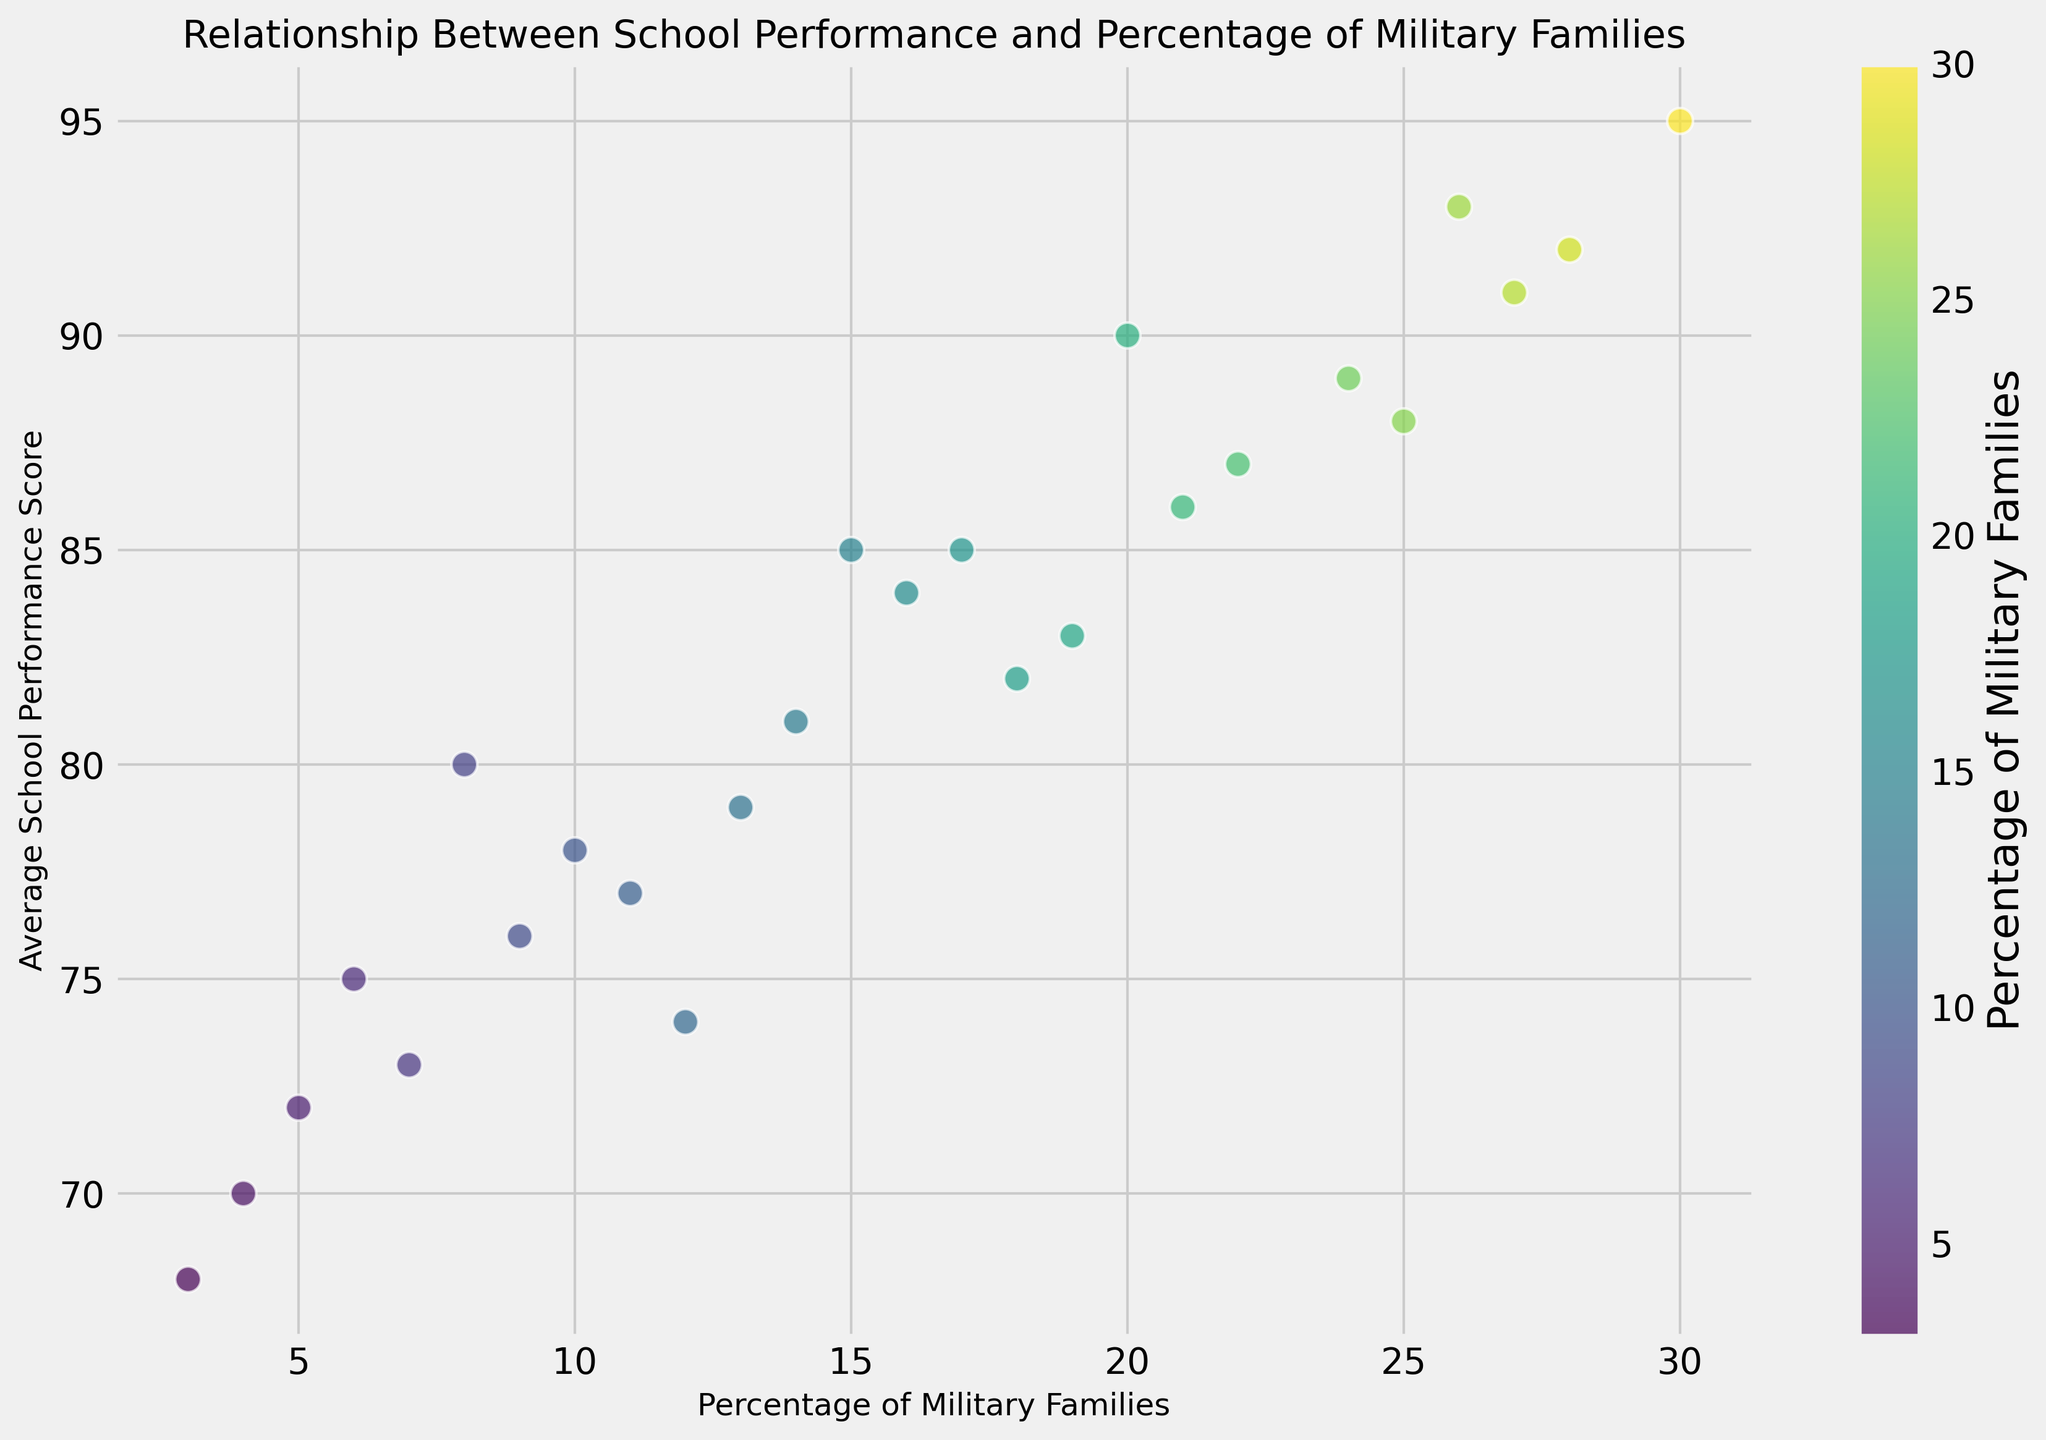What's the range of Average School Performance Scores for districts with more than 15% of military families? Identify the performance scores for Districts C, E, F, L, R, X, Z (these have more than 15% military families): {90, 88, 95, 92, 89, 91, 93}. The range is the difference between the maximum and minimum values: 95 - 88 = 7.
Answer: 7 Which district has the lowest school performance score? Look for the data point with the lowest y-coordinate. District W is at the lowest point on the y-axis with a score of 68.
Answer: District W How many districts have a percentage of military families greater than 20%? Count the data points with x-coordinates (percentage of military families) greater than 20: Districts E, F, L, R, U, X, Z. There are 7 such districts.
Answer: 7 Is there a positive or negative relationship between the percentage of military families and school performance? Observe the general trend of the scatter plot. As the percentage of military families increases (moving right on the x-axis), the school performance score generally increases (moving up on the y-axis). This indicates a positive relationship.
Answer: Positive Which district has the highest percentage of military families and what is its performance score? Find the data point furthest to the right on the x-axis. District F has the highest percentage of military families (30%) and its score is 95.
Answer: District F, 95 What is the median school performance score across all districts? Arrange the school performance scores in ascending order: {68, 70, 72, 73, 74, 75, 76, 77, 78, 79, 80, 81, 82, 83, 84, 85, 85, 86, 87, 88, 89, 90, 91, 92, 93, 95}. The median is the middle value in this ordered list (or the average of two middle values if the list has an even number of entries). There are 26 scores, so the median is the average of the 13th and 14th scores: (83+84)/2 = 83.5.
Answer: 83.5 Which district has the closest school performance score to the average of all districts’ performance scores? Calculate the average of all scores: Sum of scores = 2158, Number of scores = 26, Average = 2158/26 ≈ 83. District Q has a score of 83.
Answer: District Q Among districts with less than 10% of military families, which one has the highest school performance score? Identify the districts with less than 10% military families: Districts B, D, G, K, N, P, T, W. Their scores are {78, 72, 80, 75, 76, 70, 73, 68}. The highest performance score is 80 (District G).
Answer: District G 